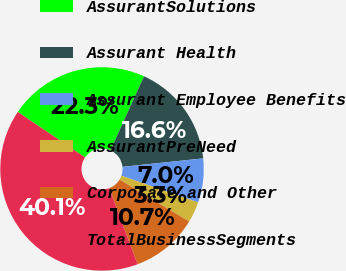<chart> <loc_0><loc_0><loc_500><loc_500><pie_chart><fcel>AssurantSolutions<fcel>Assurant Health<fcel>Assurant Employee Benefits<fcel>AssurantPreNeed<fcel>Corporate and Other<fcel>TotalBusinessSegments<nl><fcel>22.31%<fcel>16.58%<fcel>6.99%<fcel>3.31%<fcel>10.68%<fcel>40.13%<nl></chart> 